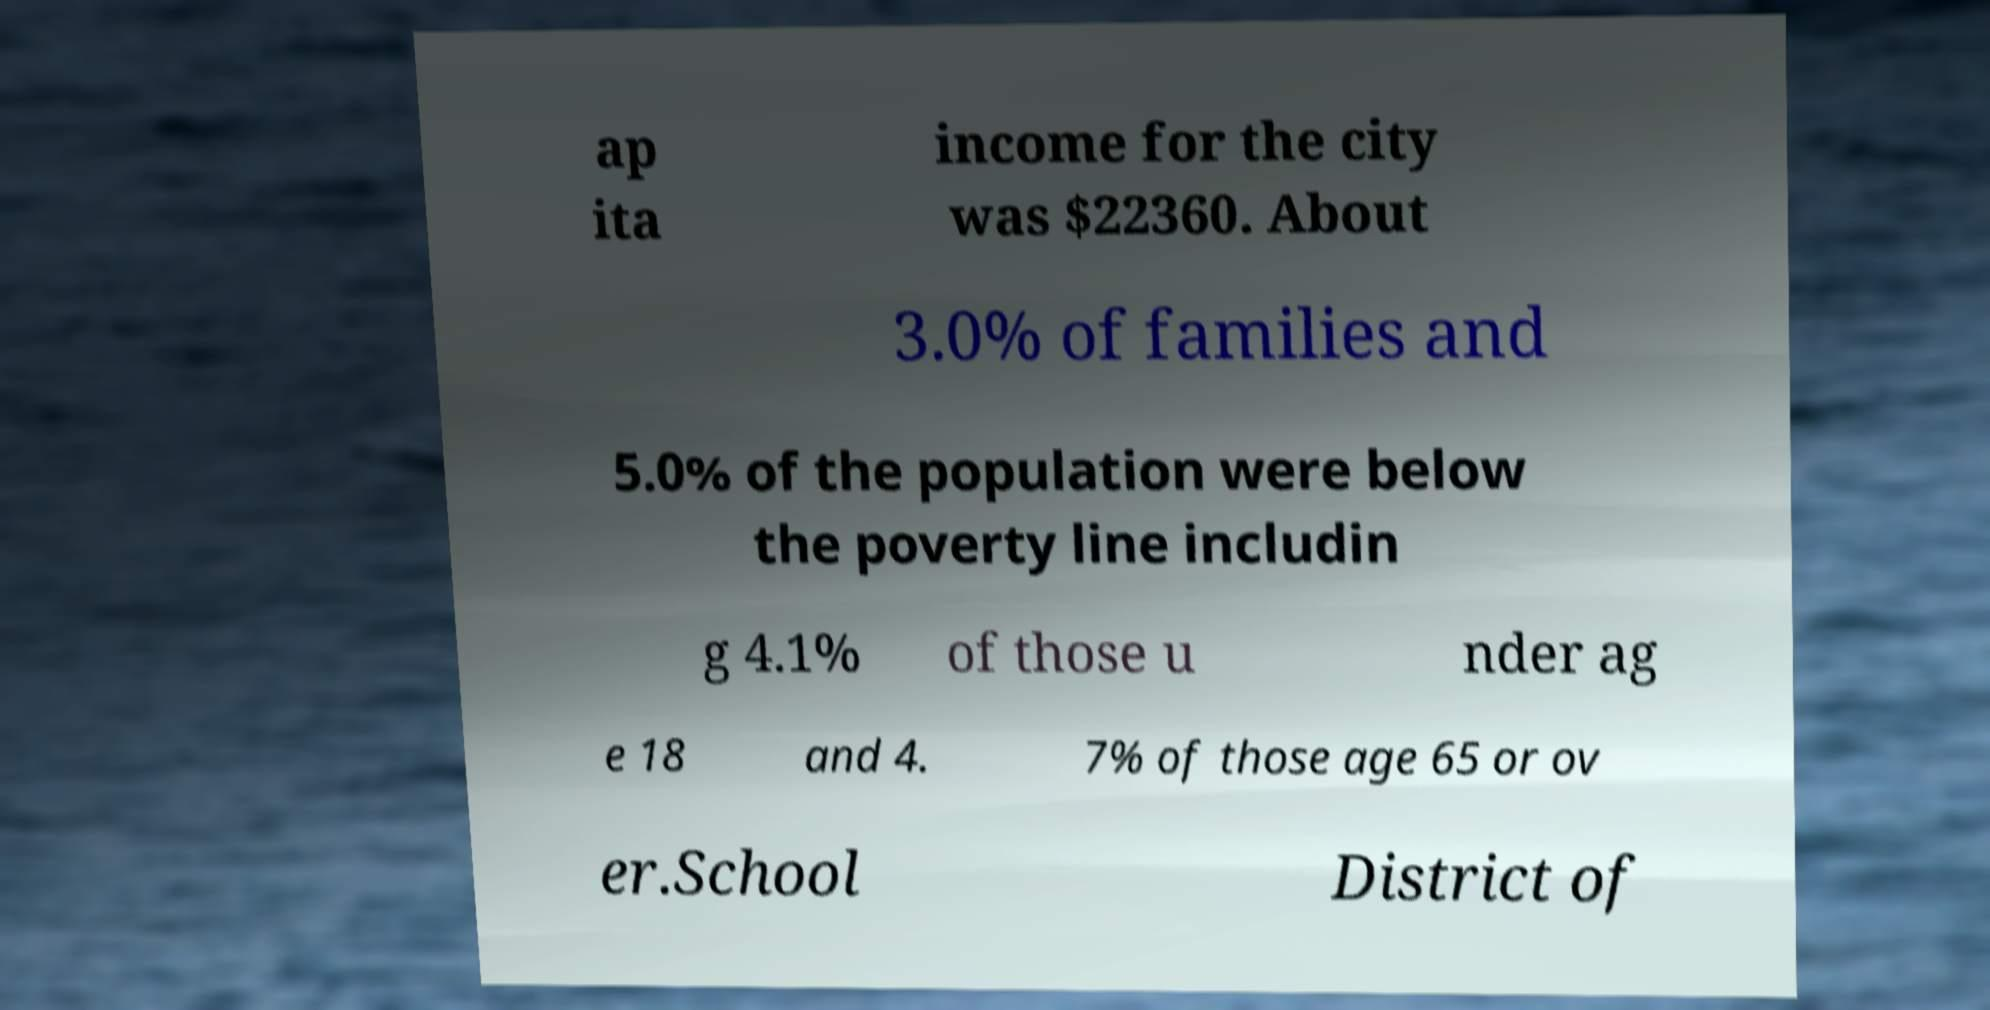What messages or text are displayed in this image? I need them in a readable, typed format. ap ita income for the city was $22360. About 3.0% of families and 5.0% of the population were below the poverty line includin g 4.1% of those u nder ag e 18 and 4. 7% of those age 65 or ov er.School District of 